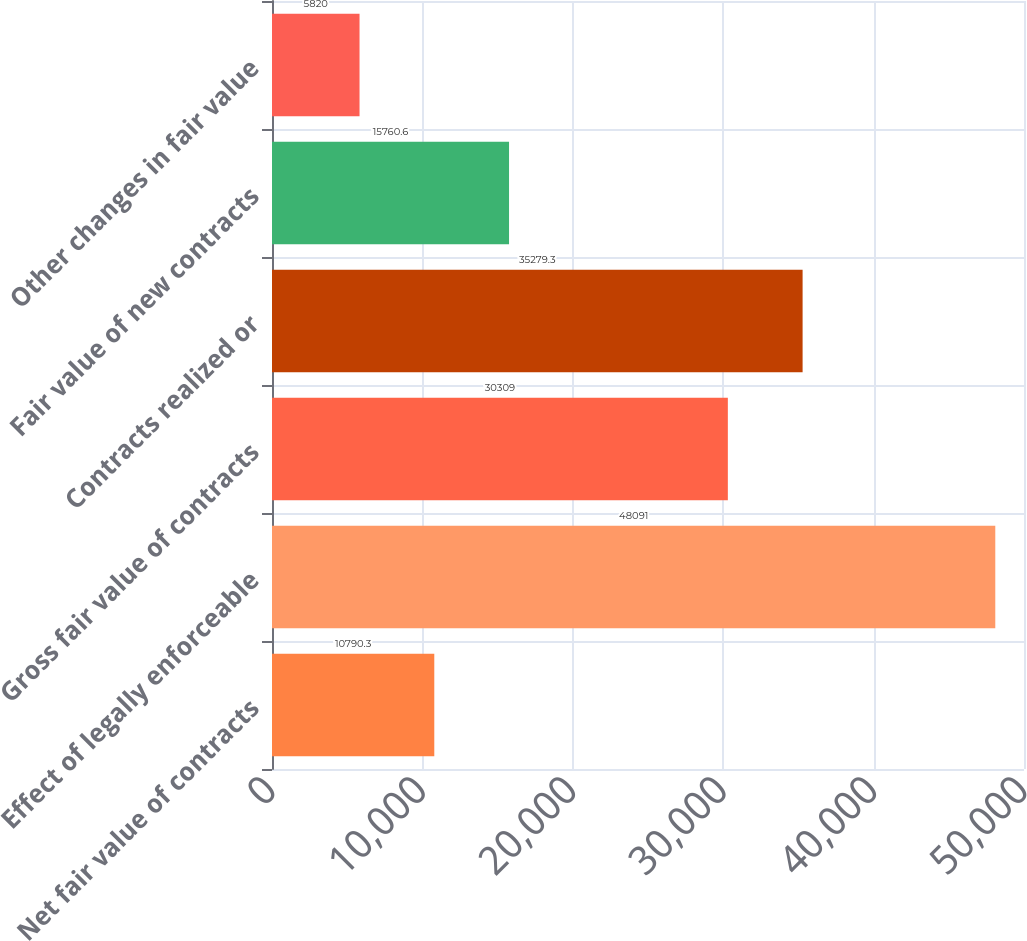<chart> <loc_0><loc_0><loc_500><loc_500><bar_chart><fcel>Net fair value of contracts<fcel>Effect of legally enforceable<fcel>Gross fair value of contracts<fcel>Contracts realized or<fcel>Fair value of new contracts<fcel>Other changes in fair value<nl><fcel>10790.3<fcel>48091<fcel>30309<fcel>35279.3<fcel>15760.6<fcel>5820<nl></chart> 